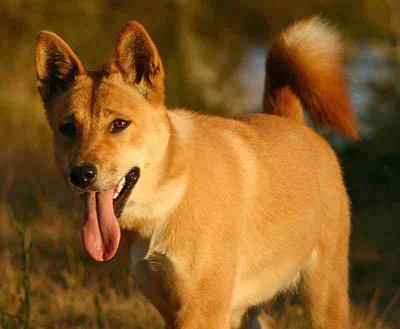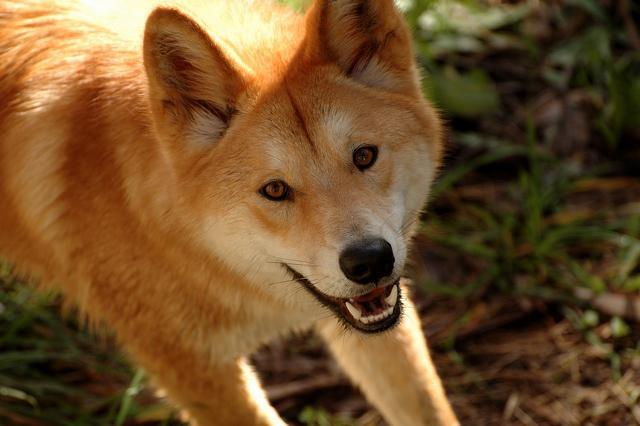The first image is the image on the left, the second image is the image on the right. Evaluate the accuracy of this statement regarding the images: "There are three dogs". Is it true? Answer yes or no. No. 